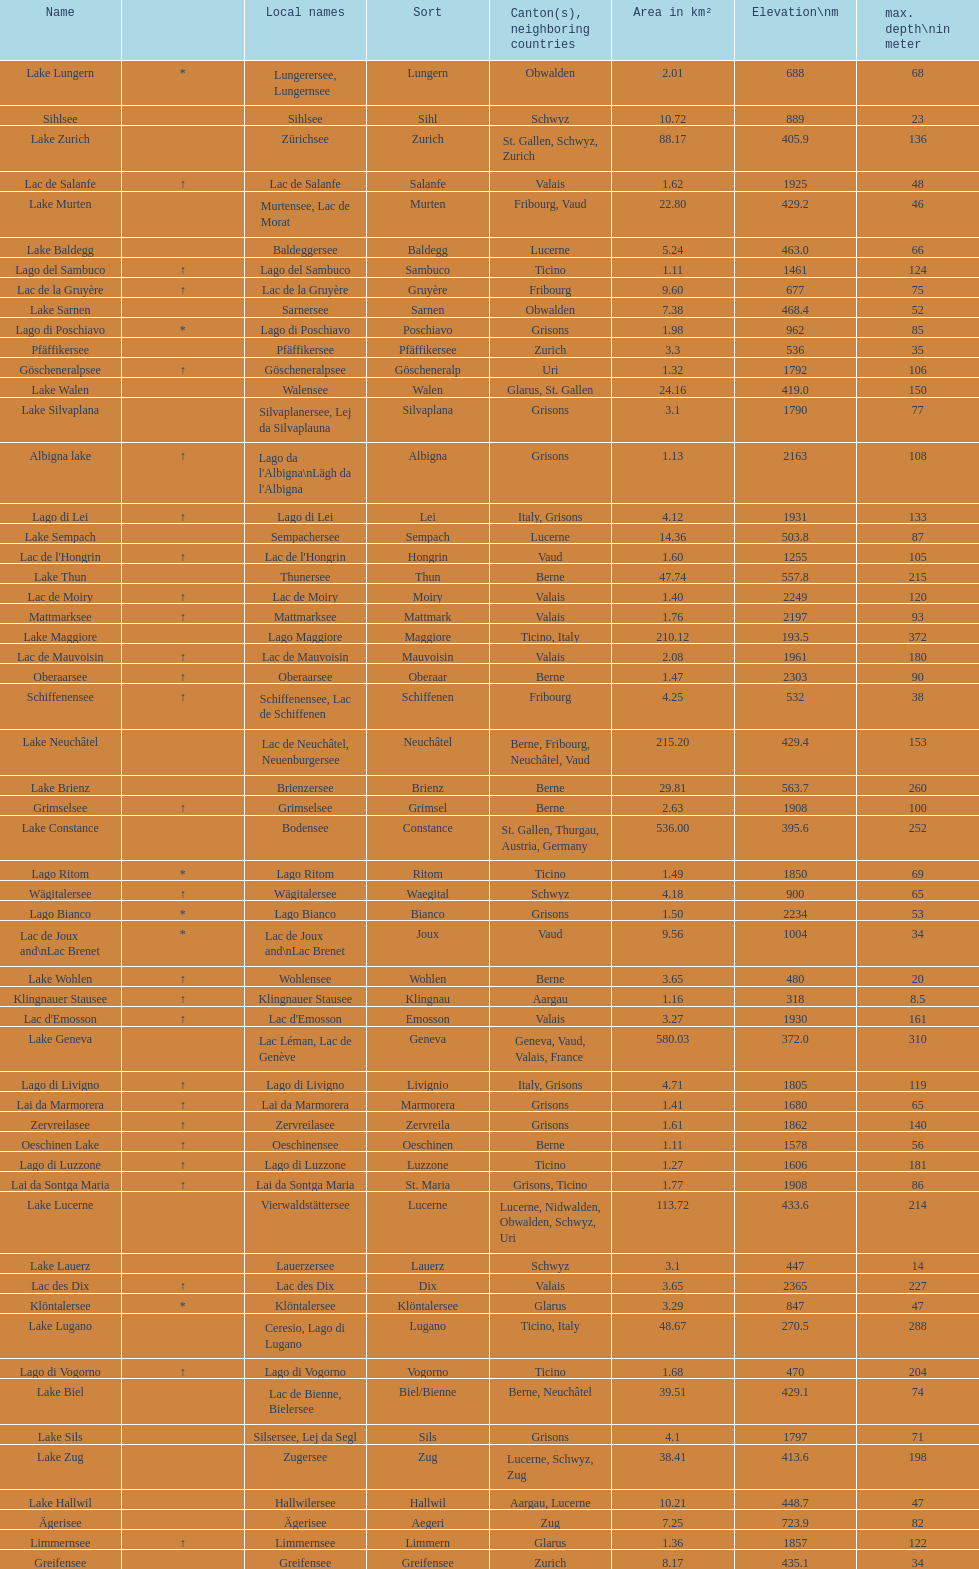What lake has the next highest elevation after lac des dix? Oberaarsee. 